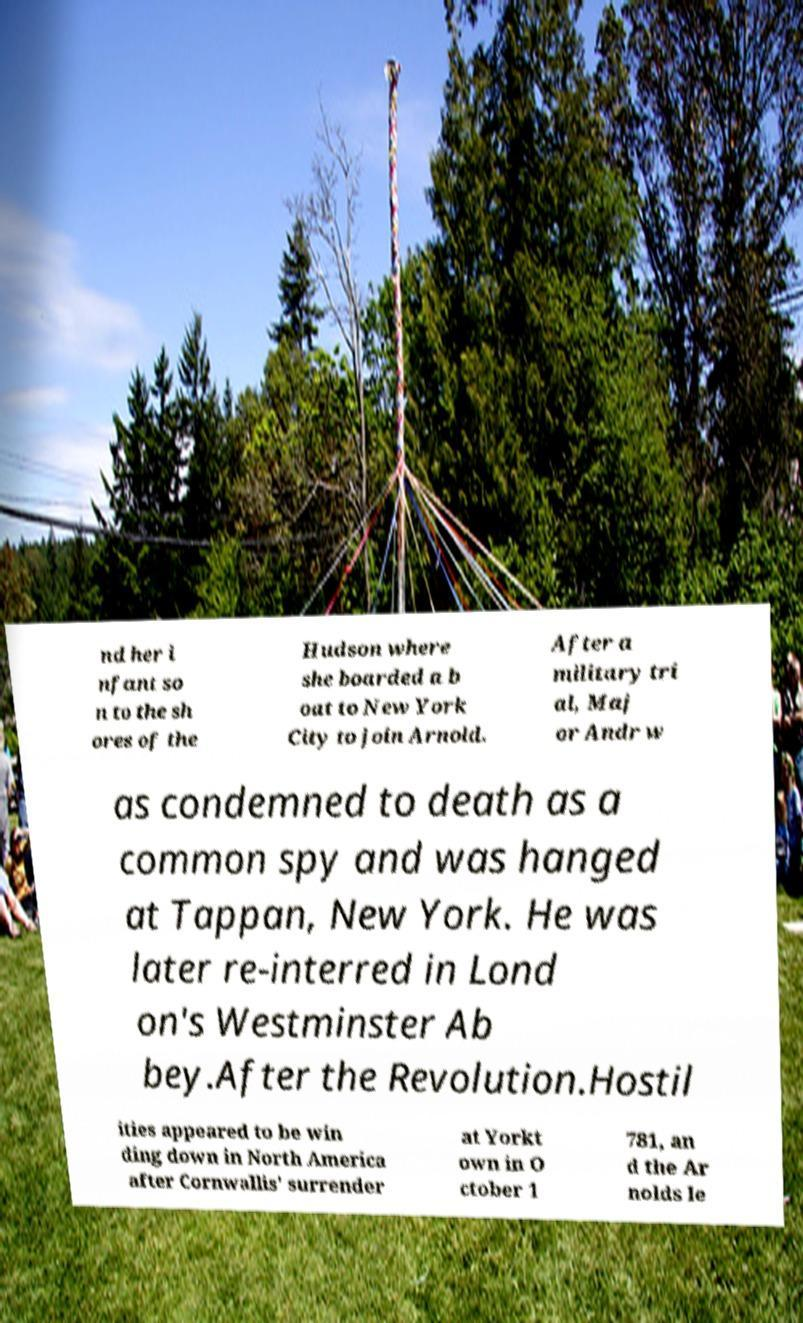Can you accurately transcribe the text from the provided image for me? nd her i nfant so n to the sh ores of the Hudson where she boarded a b oat to New York City to join Arnold. After a military tri al, Maj or Andr w as condemned to death as a common spy and was hanged at Tappan, New York. He was later re-interred in Lond on's Westminster Ab bey.After the Revolution.Hostil ities appeared to be win ding down in North America after Cornwallis' surrender at Yorkt own in O ctober 1 781, an d the Ar nolds le 